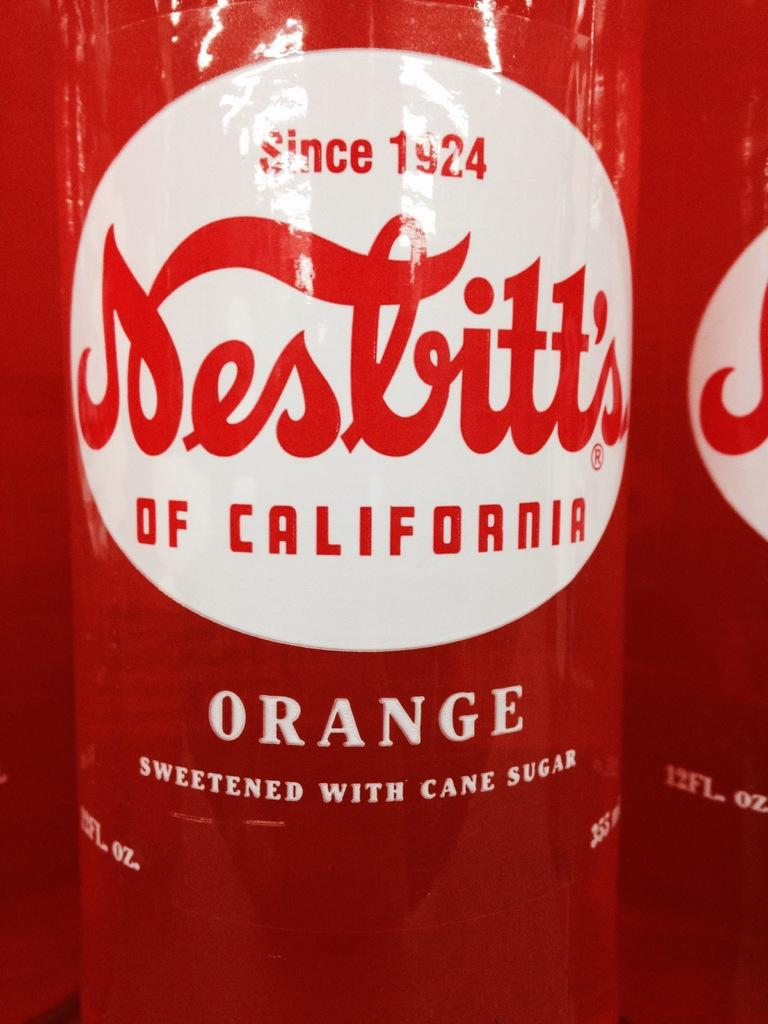<image>
Offer a succinct explanation of the picture presented. A canned beverage that is sweetened with cane sugar. 